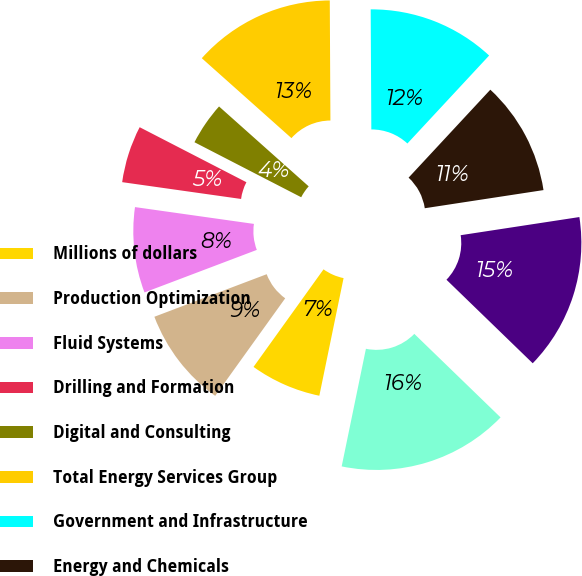Convert chart. <chart><loc_0><loc_0><loc_500><loc_500><pie_chart><fcel>Millions of dollars<fcel>Production Optimization<fcel>Fluid Systems<fcel>Drilling and Formation<fcel>Digital and Consulting<fcel>Total Energy Services Group<fcel>Government and Infrastructure<fcel>Energy and Chemicals<fcel>Total KBR<fcel>Total<nl><fcel>6.67%<fcel>9.33%<fcel>8.0%<fcel>5.34%<fcel>4.01%<fcel>13.33%<fcel>12.0%<fcel>10.67%<fcel>14.66%<fcel>15.99%<nl></chart> 